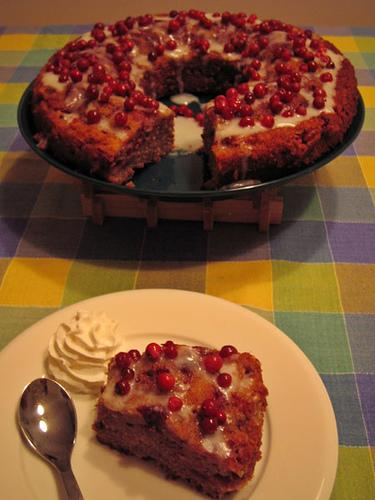Analyze the image quality based on the given information. The image quality appears to be good, with clear and detailed bounding box information for various objects and elements. What is the color and pattern of the tablecloth? The tablecloth is blue, green, and yellow with a square pattern. Name the type of fruit included in the cake. The fruit included in the cake is cranberries. Which objects on the image are interacting with the food on the plate? The silver dessert spoon is interacting with the food on the plate. Count the total number of pieces of pizza mentioned in the image. There are 10 pieces of pizza mentioned. Describe the sentiment or mood of the image. The image depicts a delicious and appetizing dessert scene, with a feeling of satisfaction and enjoyment. Provide a brief description of the objects on the plate. There is a slice of cranberry cake with white frosting and a dollop of whipped cream, served with a silver dessert spoon. How many slices of cake are mentioned in the image? There are 16 slices of cake mentioned. What is the main object on the plate, and what is the additional, smaller object on the plate? The main object on the plate is a slice of cranberry cake, and the additional, smaller object is a dollop of whipped cream. Identify the main dessert and mention the type of cake it is. The main dessert is a round cranberry bunt cake with white frosting. 